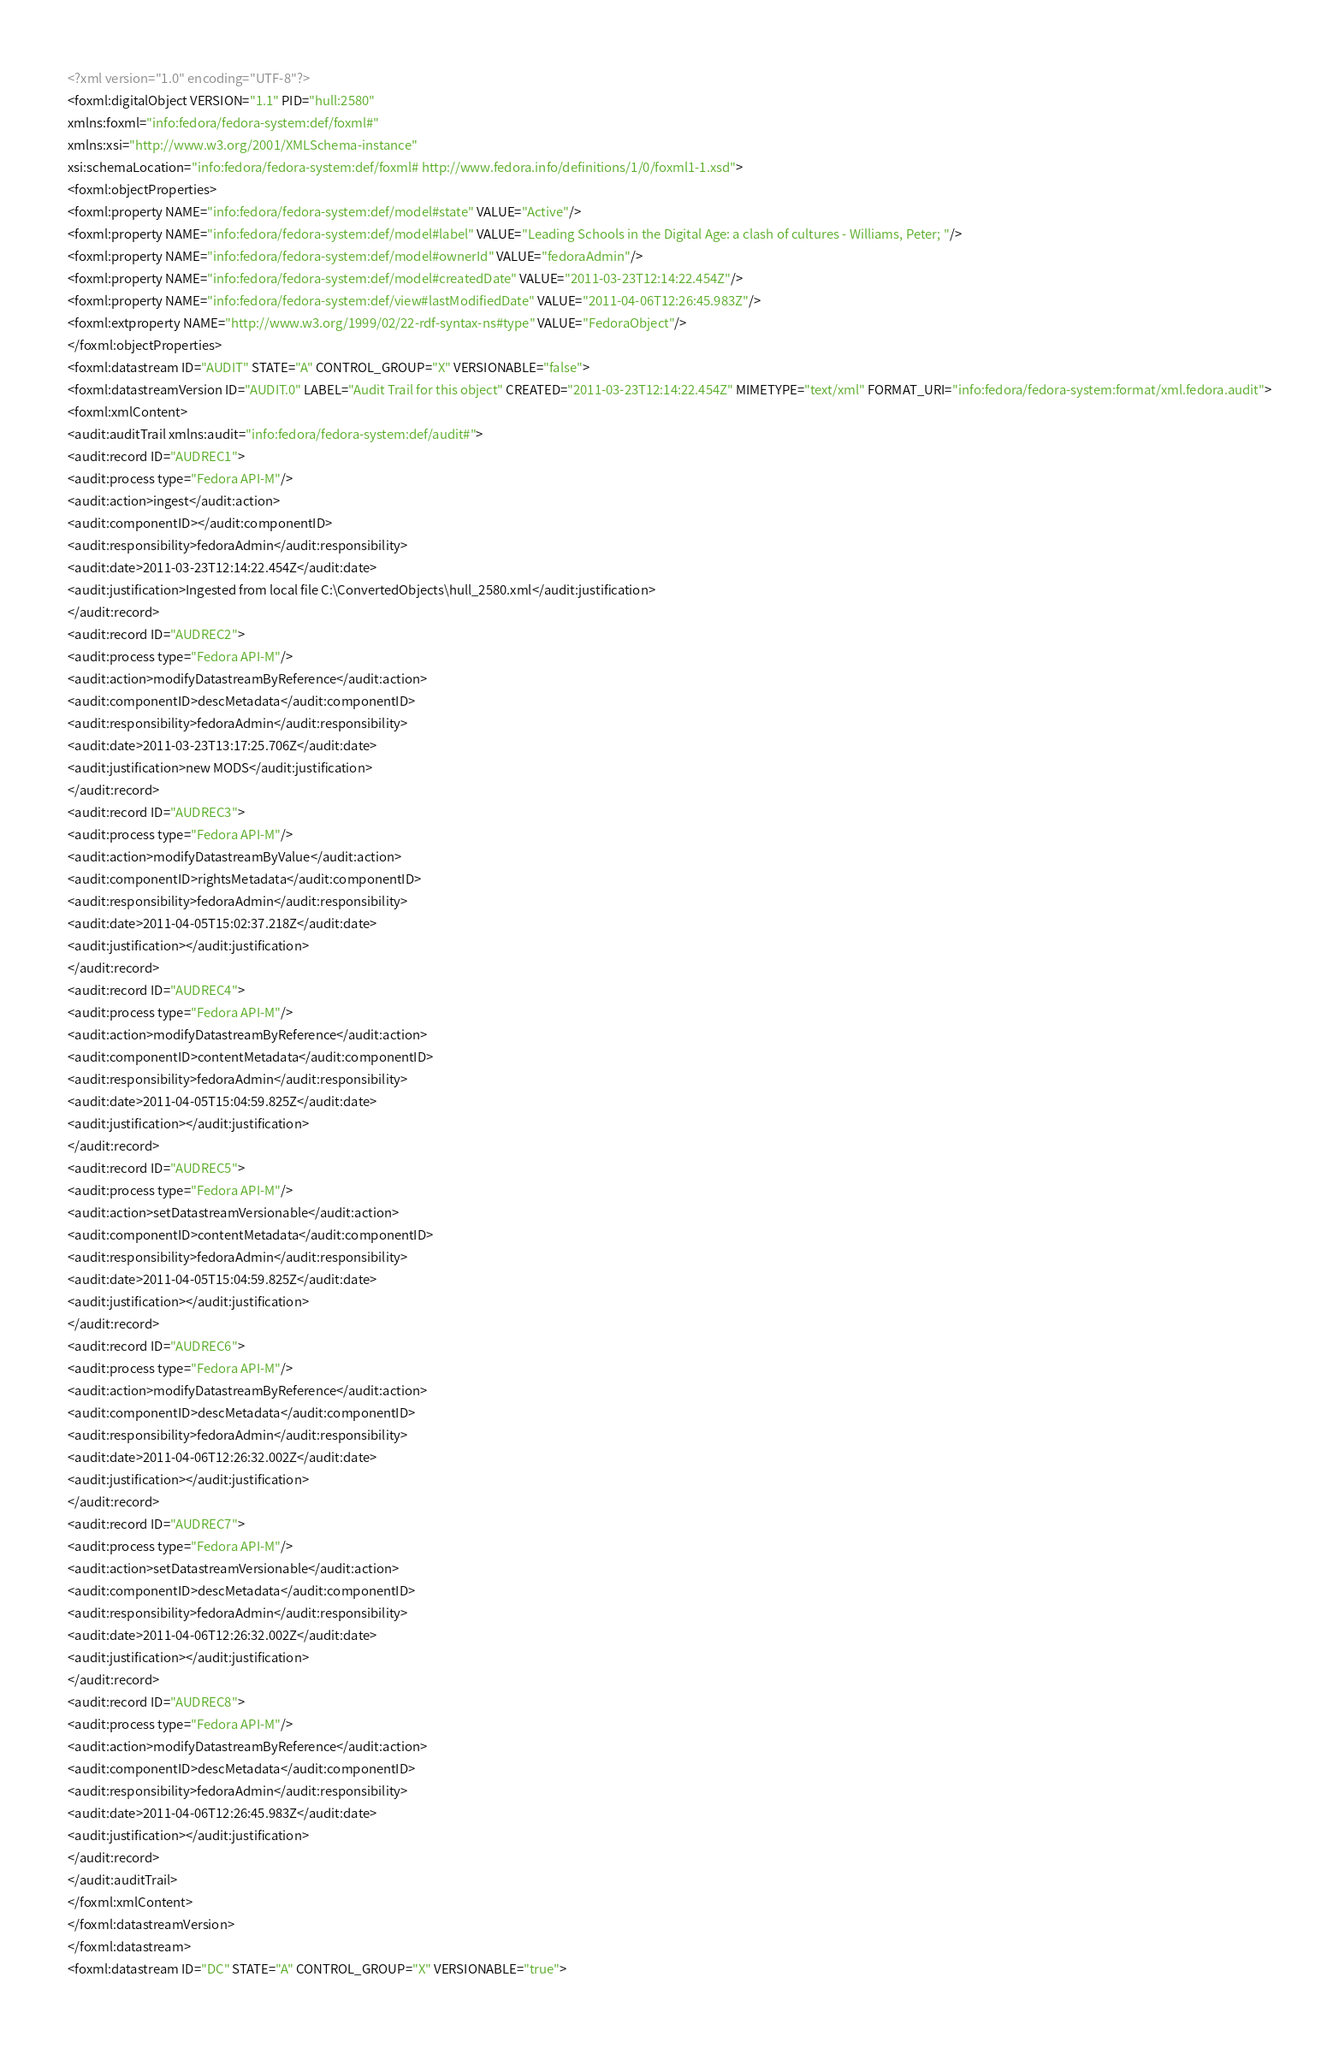<code> <loc_0><loc_0><loc_500><loc_500><_XML_><?xml version="1.0" encoding="UTF-8"?>
<foxml:digitalObject VERSION="1.1" PID="hull:2580"
xmlns:foxml="info:fedora/fedora-system:def/foxml#"
xmlns:xsi="http://www.w3.org/2001/XMLSchema-instance"
xsi:schemaLocation="info:fedora/fedora-system:def/foxml# http://www.fedora.info/definitions/1/0/foxml1-1.xsd">
<foxml:objectProperties>
<foxml:property NAME="info:fedora/fedora-system:def/model#state" VALUE="Active"/>
<foxml:property NAME="info:fedora/fedora-system:def/model#label" VALUE="Leading Schools in the Digital Age: a clash of cultures - Williams, Peter; "/>
<foxml:property NAME="info:fedora/fedora-system:def/model#ownerId" VALUE="fedoraAdmin"/>
<foxml:property NAME="info:fedora/fedora-system:def/model#createdDate" VALUE="2011-03-23T12:14:22.454Z"/>
<foxml:property NAME="info:fedora/fedora-system:def/view#lastModifiedDate" VALUE="2011-04-06T12:26:45.983Z"/>
<foxml:extproperty NAME="http://www.w3.org/1999/02/22-rdf-syntax-ns#type" VALUE="FedoraObject"/>
</foxml:objectProperties>
<foxml:datastream ID="AUDIT" STATE="A" CONTROL_GROUP="X" VERSIONABLE="false">
<foxml:datastreamVersion ID="AUDIT.0" LABEL="Audit Trail for this object" CREATED="2011-03-23T12:14:22.454Z" MIMETYPE="text/xml" FORMAT_URI="info:fedora/fedora-system:format/xml.fedora.audit">
<foxml:xmlContent>
<audit:auditTrail xmlns:audit="info:fedora/fedora-system:def/audit#">
<audit:record ID="AUDREC1">
<audit:process type="Fedora API-M"/>
<audit:action>ingest</audit:action>
<audit:componentID></audit:componentID>
<audit:responsibility>fedoraAdmin</audit:responsibility>
<audit:date>2011-03-23T12:14:22.454Z</audit:date>
<audit:justification>Ingested from local file C:\ConvertedObjects\hull_2580.xml</audit:justification>
</audit:record>
<audit:record ID="AUDREC2">
<audit:process type="Fedora API-M"/>
<audit:action>modifyDatastreamByReference</audit:action>
<audit:componentID>descMetadata</audit:componentID>
<audit:responsibility>fedoraAdmin</audit:responsibility>
<audit:date>2011-03-23T13:17:25.706Z</audit:date>
<audit:justification>new MODS</audit:justification>
</audit:record>
<audit:record ID="AUDREC3">
<audit:process type="Fedora API-M"/>
<audit:action>modifyDatastreamByValue</audit:action>
<audit:componentID>rightsMetadata</audit:componentID>
<audit:responsibility>fedoraAdmin</audit:responsibility>
<audit:date>2011-04-05T15:02:37.218Z</audit:date>
<audit:justification></audit:justification>
</audit:record>
<audit:record ID="AUDREC4">
<audit:process type="Fedora API-M"/>
<audit:action>modifyDatastreamByReference</audit:action>
<audit:componentID>contentMetadata</audit:componentID>
<audit:responsibility>fedoraAdmin</audit:responsibility>
<audit:date>2011-04-05T15:04:59.825Z</audit:date>
<audit:justification></audit:justification>
</audit:record>
<audit:record ID="AUDREC5">
<audit:process type="Fedora API-M"/>
<audit:action>setDatastreamVersionable</audit:action>
<audit:componentID>contentMetadata</audit:componentID>
<audit:responsibility>fedoraAdmin</audit:responsibility>
<audit:date>2011-04-05T15:04:59.825Z</audit:date>
<audit:justification></audit:justification>
</audit:record>
<audit:record ID="AUDREC6">
<audit:process type="Fedora API-M"/>
<audit:action>modifyDatastreamByReference</audit:action>
<audit:componentID>descMetadata</audit:componentID>
<audit:responsibility>fedoraAdmin</audit:responsibility>
<audit:date>2011-04-06T12:26:32.002Z</audit:date>
<audit:justification></audit:justification>
</audit:record>
<audit:record ID="AUDREC7">
<audit:process type="Fedora API-M"/>
<audit:action>setDatastreamVersionable</audit:action>
<audit:componentID>descMetadata</audit:componentID>
<audit:responsibility>fedoraAdmin</audit:responsibility>
<audit:date>2011-04-06T12:26:32.002Z</audit:date>
<audit:justification></audit:justification>
</audit:record>
<audit:record ID="AUDREC8">
<audit:process type="Fedora API-M"/>
<audit:action>modifyDatastreamByReference</audit:action>
<audit:componentID>descMetadata</audit:componentID>
<audit:responsibility>fedoraAdmin</audit:responsibility>
<audit:date>2011-04-06T12:26:45.983Z</audit:date>
<audit:justification></audit:justification>
</audit:record>
</audit:auditTrail>
</foxml:xmlContent>
</foxml:datastreamVersion>
</foxml:datastream>
<foxml:datastream ID="DC" STATE="A" CONTROL_GROUP="X" VERSIONABLE="true"></code> 